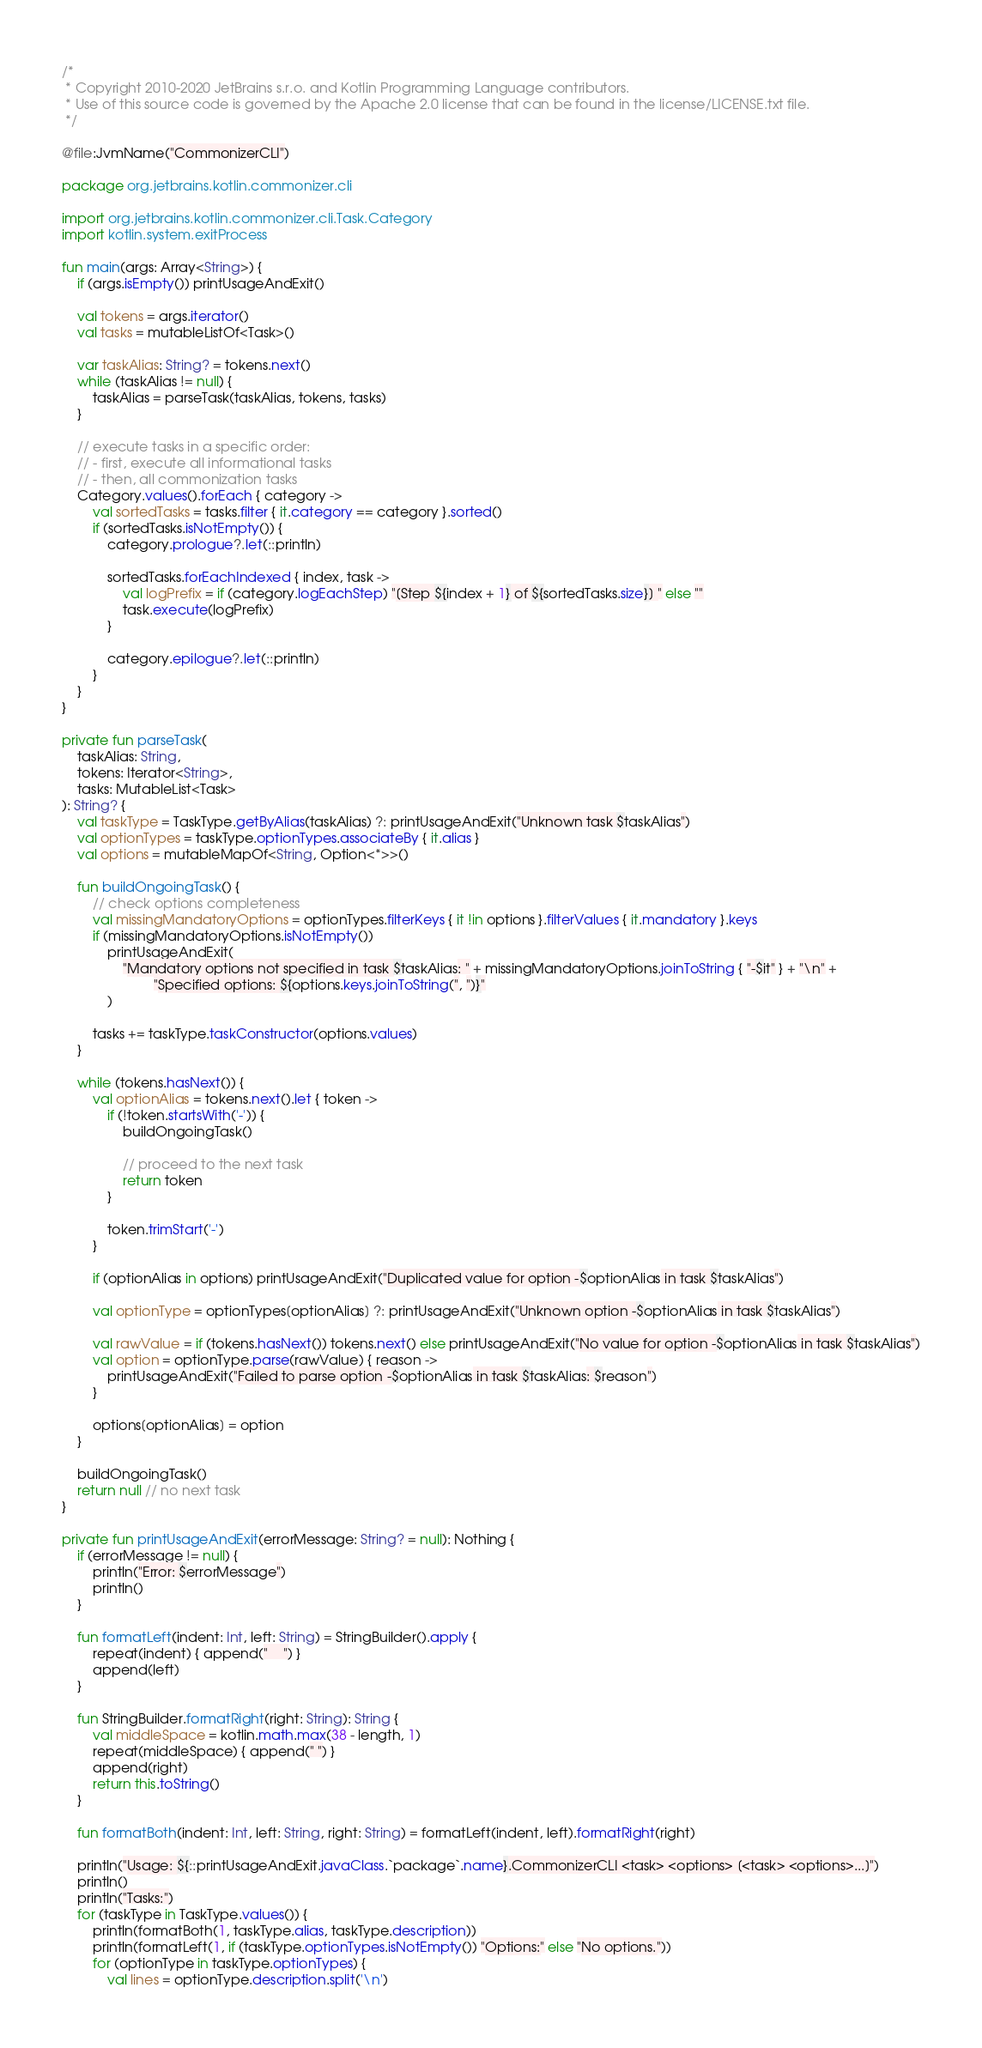<code> <loc_0><loc_0><loc_500><loc_500><_Kotlin_>/*
 * Copyright 2010-2020 JetBrains s.r.o. and Kotlin Programming Language contributors.
 * Use of this source code is governed by the Apache 2.0 license that can be found in the license/LICENSE.txt file.
 */

@file:JvmName("CommonizerCLI")

package org.jetbrains.kotlin.commonizer.cli

import org.jetbrains.kotlin.commonizer.cli.Task.Category
import kotlin.system.exitProcess

fun main(args: Array<String>) {
    if (args.isEmpty()) printUsageAndExit()

    val tokens = args.iterator()
    val tasks = mutableListOf<Task>()

    var taskAlias: String? = tokens.next()
    while (taskAlias != null) {
        taskAlias = parseTask(taskAlias, tokens, tasks)
    }

    // execute tasks in a specific order:
    // - first, execute all informational tasks
    // - then, all commonization tasks
    Category.values().forEach { category ->
        val sortedTasks = tasks.filter { it.category == category }.sorted()
        if (sortedTasks.isNotEmpty()) {
            category.prologue?.let(::println)

            sortedTasks.forEachIndexed { index, task ->
                val logPrefix = if (category.logEachStep) "[Step ${index + 1} of ${sortedTasks.size}] " else ""
                task.execute(logPrefix)
            }

            category.epilogue?.let(::println)
        }
    }
}

private fun parseTask(
    taskAlias: String,
    tokens: Iterator<String>,
    tasks: MutableList<Task>
): String? {
    val taskType = TaskType.getByAlias(taskAlias) ?: printUsageAndExit("Unknown task $taskAlias")
    val optionTypes = taskType.optionTypes.associateBy { it.alias }
    val options = mutableMapOf<String, Option<*>>()

    fun buildOngoingTask() {
        // check options completeness
        val missingMandatoryOptions = optionTypes.filterKeys { it !in options }.filterValues { it.mandatory }.keys
        if (missingMandatoryOptions.isNotEmpty())
            printUsageAndExit(
                "Mandatory options not specified in task $taskAlias: " + missingMandatoryOptions.joinToString { "-$it" } + "\n" +
                        "Specified options: ${options.keys.joinToString(", ")}"
            )

        tasks += taskType.taskConstructor(options.values)
    }

    while (tokens.hasNext()) {
        val optionAlias = tokens.next().let { token ->
            if (!token.startsWith('-')) {
                buildOngoingTask()

                // proceed to the next task
                return token
            }

            token.trimStart('-')
        }

        if (optionAlias in options) printUsageAndExit("Duplicated value for option -$optionAlias in task $taskAlias")

        val optionType = optionTypes[optionAlias] ?: printUsageAndExit("Unknown option -$optionAlias in task $taskAlias")

        val rawValue = if (tokens.hasNext()) tokens.next() else printUsageAndExit("No value for option -$optionAlias in task $taskAlias")
        val option = optionType.parse(rawValue) { reason ->
            printUsageAndExit("Failed to parse option -$optionAlias in task $taskAlias: $reason")
        }

        options[optionAlias] = option
    }

    buildOngoingTask()
    return null // no next task
}

private fun printUsageAndExit(errorMessage: String? = null): Nothing {
    if (errorMessage != null) {
        println("Error: $errorMessage")
        println()
    }

    fun formatLeft(indent: Int, left: String) = StringBuilder().apply {
        repeat(indent) { append("    ") }
        append(left)
    }

    fun StringBuilder.formatRight(right: String): String {
        val middleSpace = kotlin.math.max(38 - length, 1)
        repeat(middleSpace) { append(" ") }
        append(right)
        return this.toString()
    }

    fun formatBoth(indent: Int, left: String, right: String) = formatLeft(indent, left).formatRight(right)

    println("Usage: ${::printUsageAndExit.javaClass.`package`.name}.CommonizerCLI <task> <options> [<task> <options>...]")
    println()
    println("Tasks:")
    for (taskType in TaskType.values()) {
        println(formatBoth(1, taskType.alias, taskType.description))
        println(formatLeft(1, if (taskType.optionTypes.isNotEmpty()) "Options:" else "No options."))
        for (optionType in taskType.optionTypes) {
            val lines = optionType.description.split('\n')</code> 